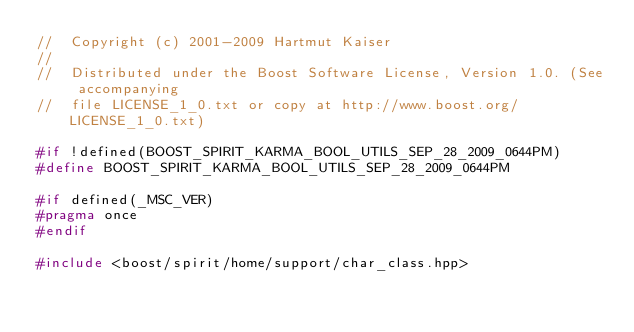<code> <loc_0><loc_0><loc_500><loc_500><_C++_>//  Copyright (c) 2001-2009 Hartmut Kaiser
// 
//  Distributed under the Boost Software License, Version 1.0. (See accompanying 
//  file LICENSE_1_0.txt or copy at http://www.boost.org/LICENSE_1_0.txt)

#if !defined(BOOST_SPIRIT_KARMA_BOOL_UTILS_SEP_28_2009_0644PM)
#define BOOST_SPIRIT_KARMA_BOOL_UTILS_SEP_28_2009_0644PM

#if defined(_MSC_VER)
#pragma once
#endif

#include <boost/spirit/home/support/char_class.hpp></code> 